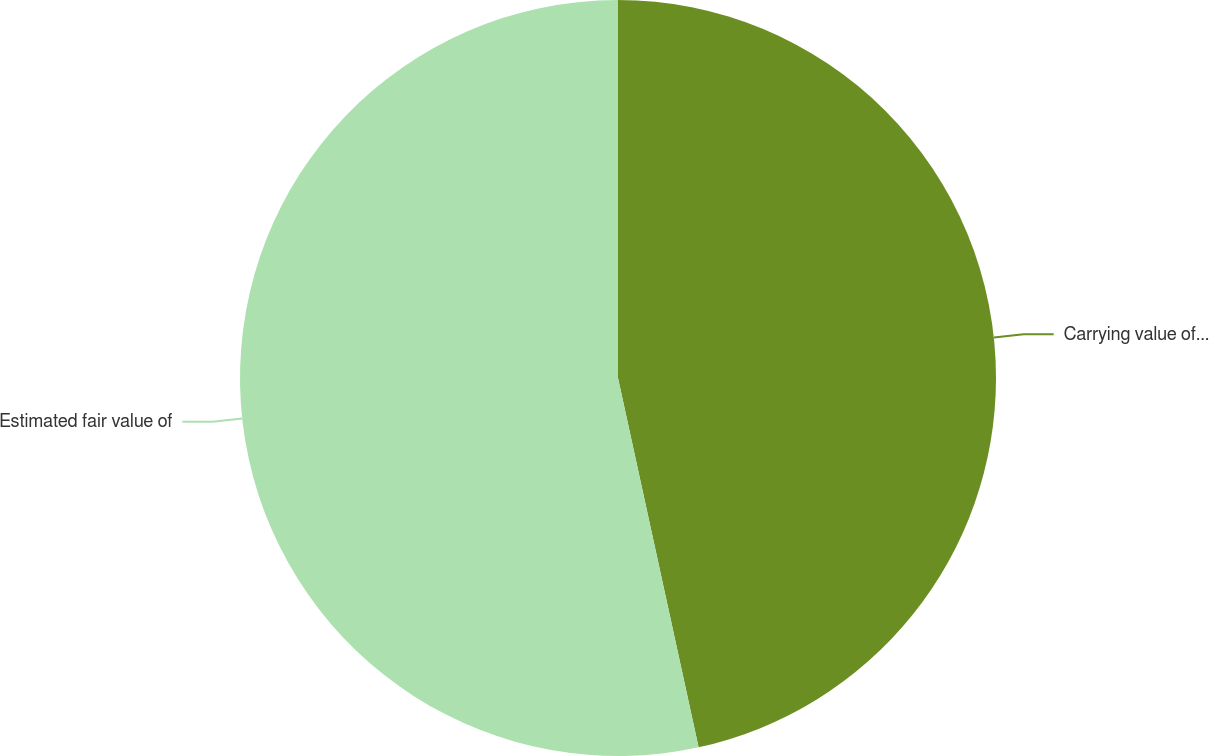Convert chart to OTSL. <chart><loc_0><loc_0><loc_500><loc_500><pie_chart><fcel>Carrying value of long-term<fcel>Estimated fair value of<nl><fcel>46.58%<fcel>53.42%<nl></chart> 